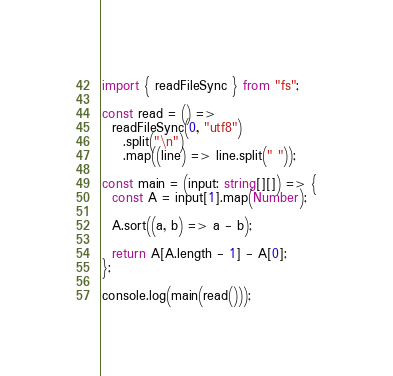Convert code to text. <code><loc_0><loc_0><loc_500><loc_500><_TypeScript_>import { readFileSync } from "fs";

const read = () =>
  readFileSync(0, "utf8")
    .split("\n")
    .map((line) => line.split(" "));

const main = (input: string[][]) => {
  const A = input[1].map(Number);

  A.sort((a, b) => a - b);

  return A[A.length - 1] - A[0];
};

console.log(main(read()));
</code> 